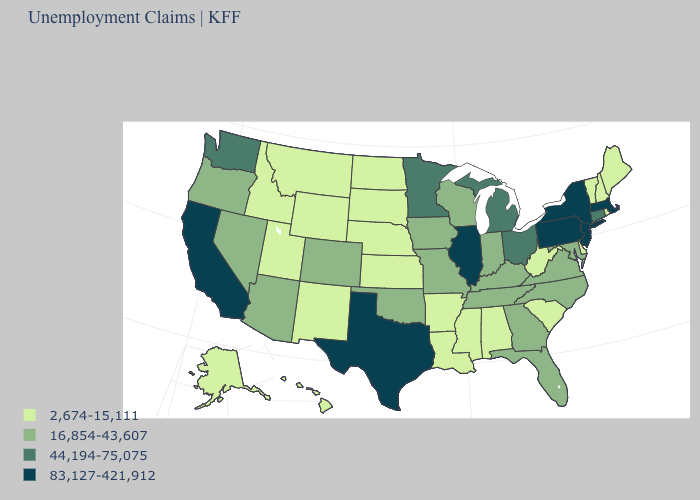Among the states that border Connecticut , which have the lowest value?
Quick response, please. Rhode Island. What is the highest value in the MidWest ?
Short answer required. 83,127-421,912. What is the value of Kentucky?
Quick response, please. 16,854-43,607. Is the legend a continuous bar?
Answer briefly. No. What is the value of North Carolina?
Concise answer only. 16,854-43,607. Among the states that border North Dakota , does Minnesota have the highest value?
Concise answer only. Yes. What is the highest value in states that border North Carolina?
Keep it brief. 16,854-43,607. What is the lowest value in the USA?
Concise answer only. 2,674-15,111. What is the highest value in the USA?
Give a very brief answer. 83,127-421,912. Does Indiana have the lowest value in the MidWest?
Quick response, please. No. Does Virginia have a higher value than Utah?
Concise answer only. Yes. What is the highest value in states that border New Mexico?
Quick response, please. 83,127-421,912. What is the value of Missouri?
Be succinct. 16,854-43,607. Which states have the lowest value in the West?
Write a very short answer. Alaska, Hawaii, Idaho, Montana, New Mexico, Utah, Wyoming. Name the states that have a value in the range 2,674-15,111?
Give a very brief answer. Alabama, Alaska, Arkansas, Delaware, Hawaii, Idaho, Kansas, Louisiana, Maine, Mississippi, Montana, Nebraska, New Hampshire, New Mexico, North Dakota, Rhode Island, South Carolina, South Dakota, Utah, Vermont, West Virginia, Wyoming. 